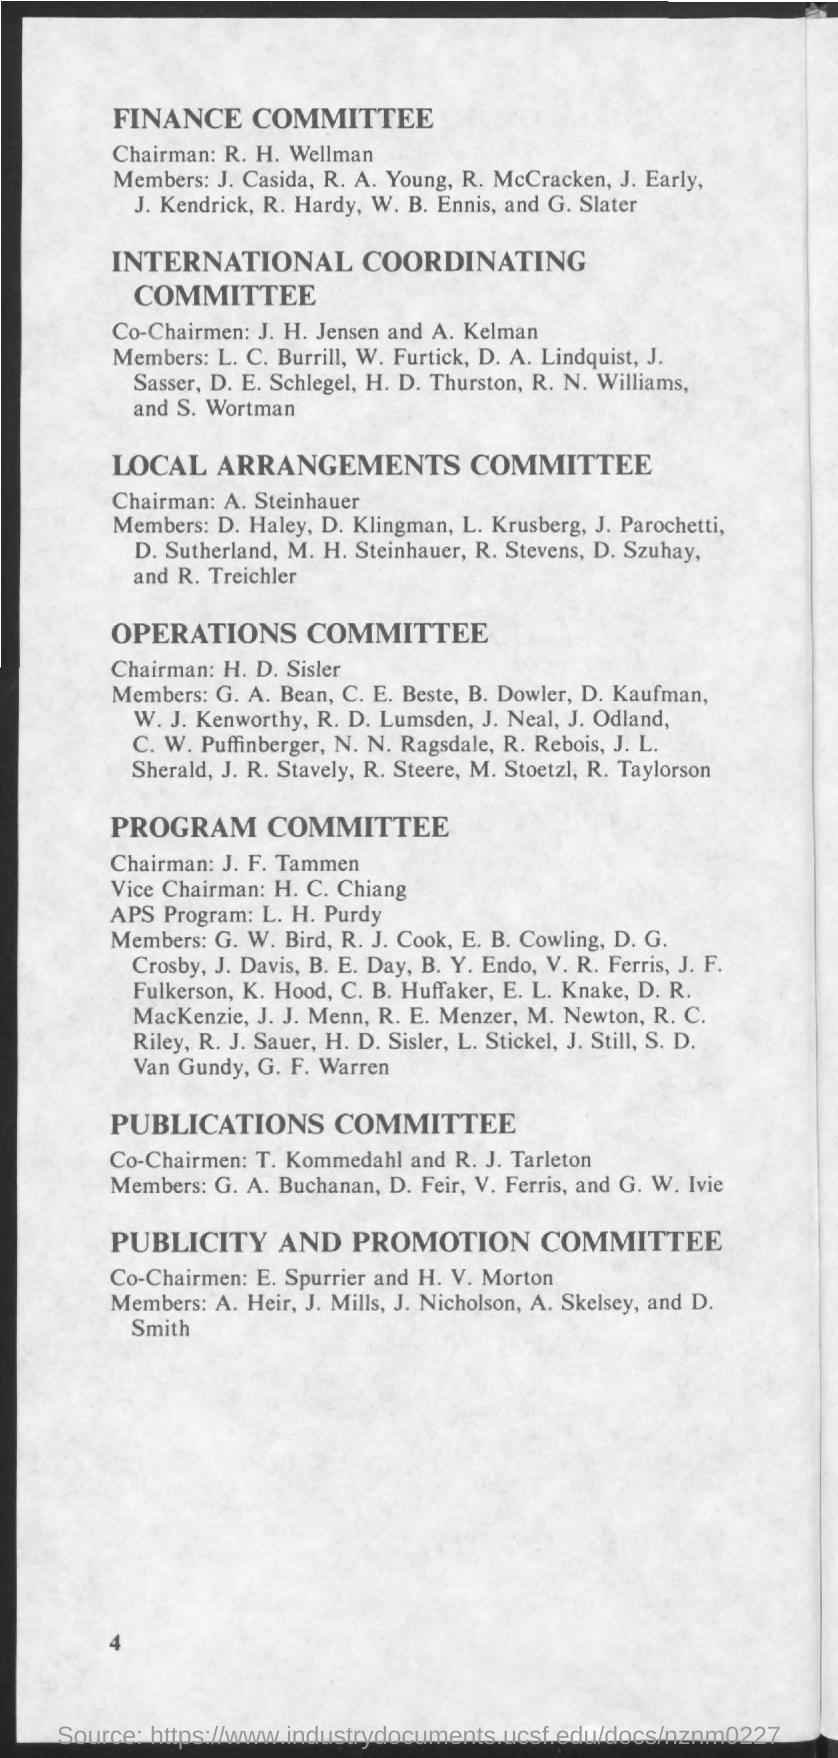Who is the chairman for Finance Committee?
Ensure brevity in your answer.  R. H. Wellman. Who is the Co-Chairmen for Inernational Coordinating committee?
Provide a succinct answer. J. H. Jensen and A. Kelman. 